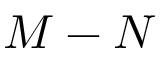<formula> <loc_0><loc_0><loc_500><loc_500>M - N</formula> 